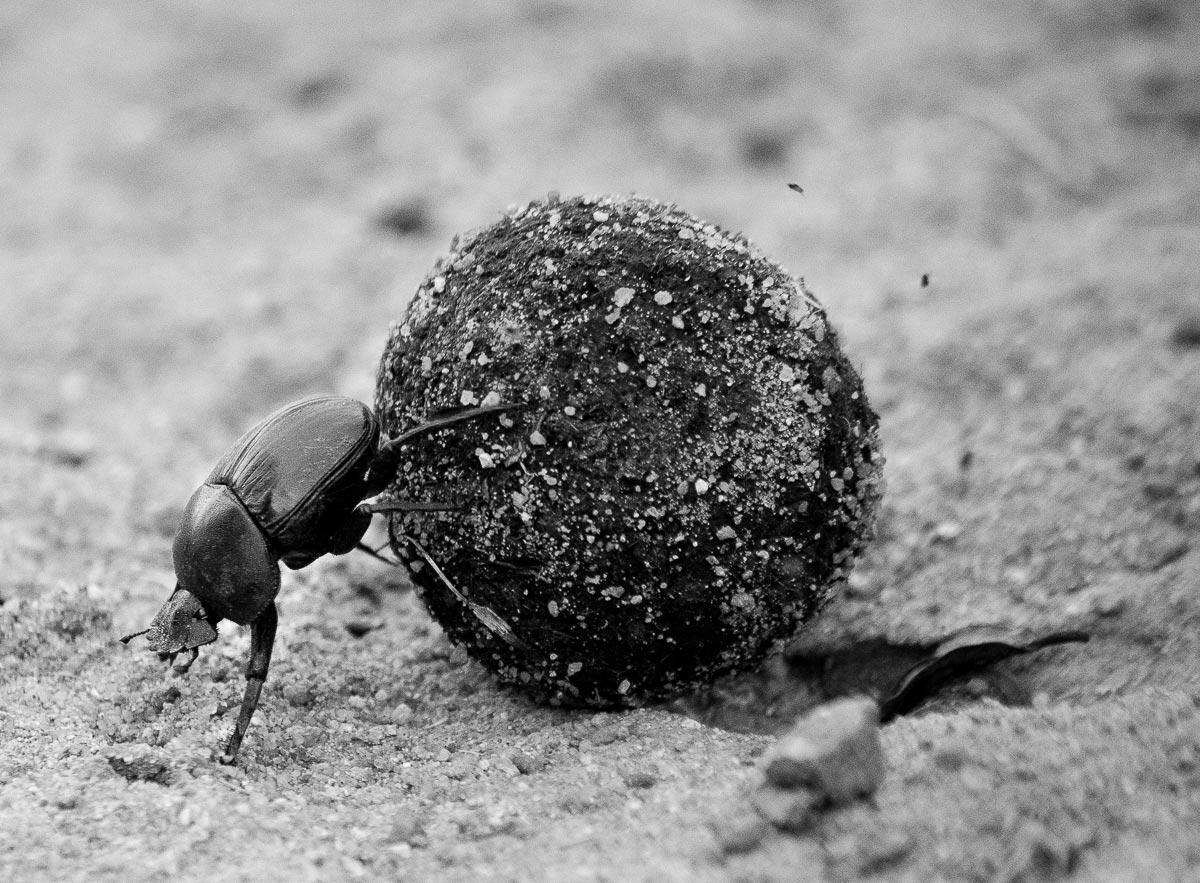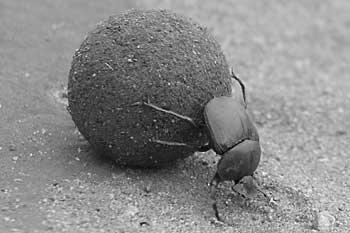The first image is the image on the left, the second image is the image on the right. Examine the images to the left and right. Is the description "In one image there is a dung beetle on the right side of the dung ball with its head toward the ground." accurate? Answer yes or no. Yes. The first image is the image on the left, the second image is the image on the right. Analyze the images presented: Is the assertion "A dug beetle with a ball of dug is pictured in black and white." valid? Answer yes or no. Yes. 